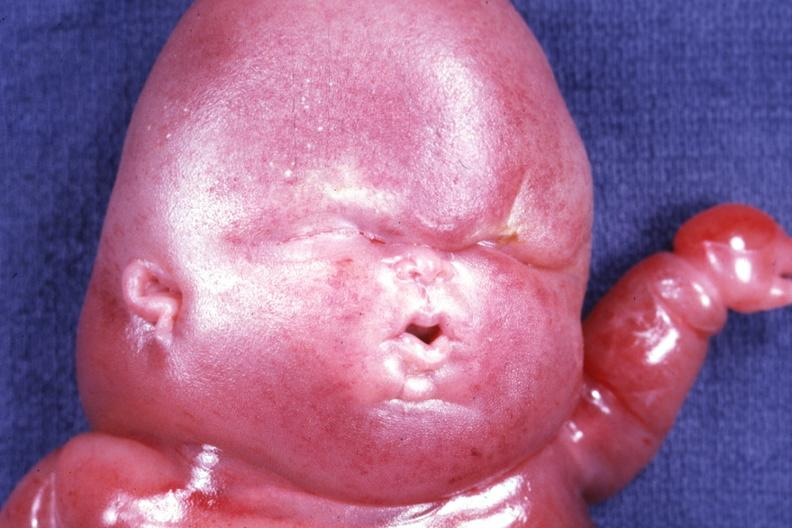what does this image show?
Answer the question using a single word or phrase. Mostly head in photo gory edema 